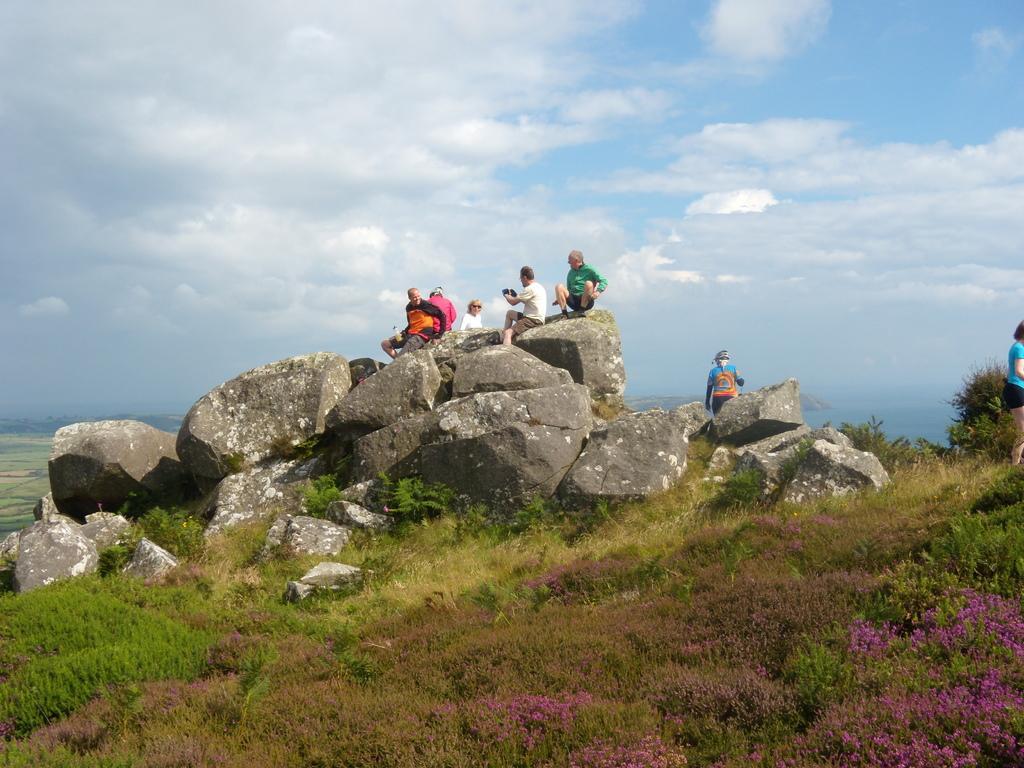Can you describe this image briefly? This image consists of few persons sitting on the rocks. At the bottom, there is green grass. In the background, we can see the clouds in the sky. 